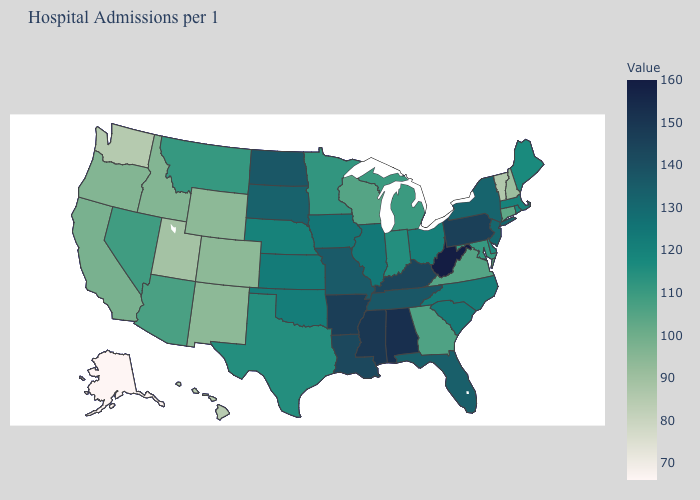Does Michigan have a lower value than Wyoming?
Answer briefly. No. Among the states that border Florida , which have the lowest value?
Short answer required. Georgia. Does Wisconsin have the lowest value in the MidWest?
Answer briefly. Yes. Does Vermont have the lowest value in the Northeast?
Concise answer only. Yes. 